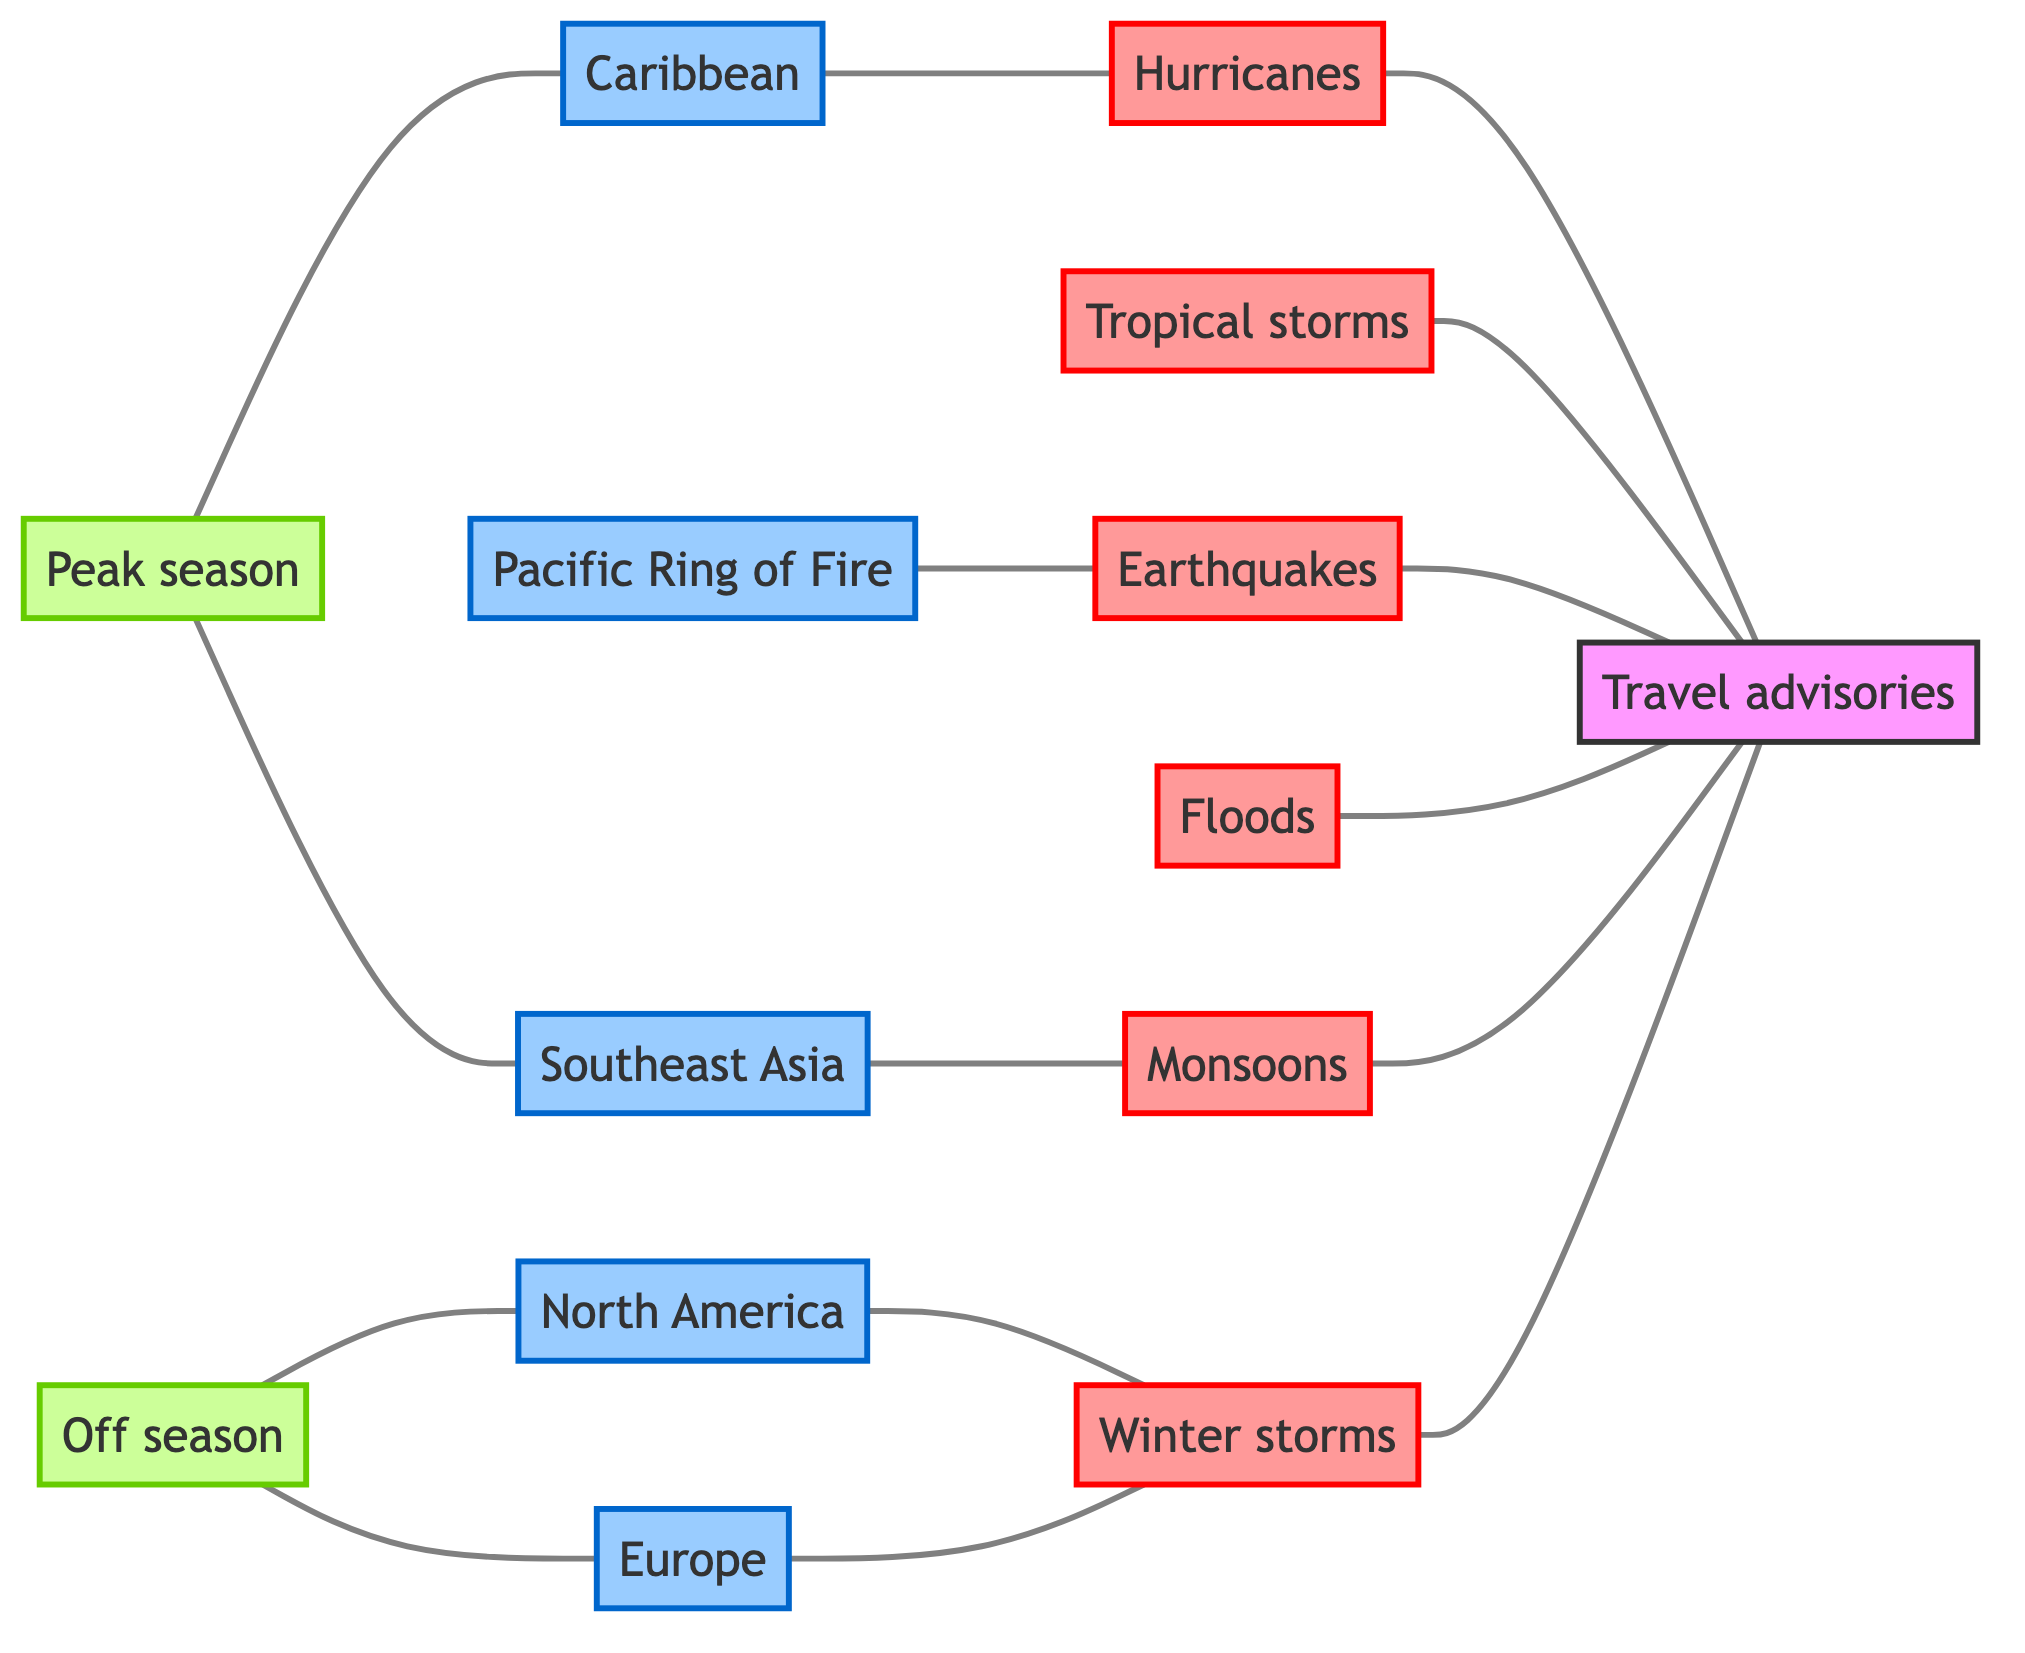What's the number of natural disaster nodes in the diagram? Count the nodes classified as disasters in the diagram. These are: Hurricanes, Tropical storms, Earthquakes, Floods, Monsoons, and Winter storms. Thus, there are six nodes labeled as natural disasters.
Answer: 6 Which region is associated with monsoons? Check the edges in the diagram to see which region connects to 'Monsoons'. The edge indicates that 'Southeast Asia' is linked to 'Monsoons'.
Answer: Southeast Asia How many types of travel advisories are influenced by natural disasters? Identify the connections from natural disaster nodes to the 'Travel advisories' node in the diagram. Since all six disaster nodes connect to 'Travel advisories', this indicates six types of advisories.
Answer: 6 Which region is directly linked to hurricanes? Review the edges connected to 'Hurricanes'. 'Caribbean' is directly linked to 'Hurricanes' in the diagram.
Answer: Caribbean Is there a connection between tropical storms and any specific travel advisory? Look for direct edges from 'Tropical storms' to other nodes. The 'Tropical storms' node connects directly to the 'Travel advisories' node, indicating a relationship.
Answer: Yes What are the two types of seasons represented in the diagram? The diagram contains the nodes 'Peak season' and 'Off season', which are both labeled as types of seasons.
Answer: Peak season, Off season Which natural disaster is associated with the Pacific Ring of Fire? Inspect the diagrams and edges for natural disasters linked to 'Pacific Ring of Fire'. The 'Earthquakes' node is connected to it, showing that earthquakes are relevant to this region.
Answer: Earthquakes What is the relationship between North America and winter storms? Examine the connection between 'North America' and 'Winter storms'. A direct edge shows a link, indicating that winter storms are relevant for North America.
Answer: Relevant Which region experiences tropical storms based on the diagram? Analyze the edges for any connection to 'Tropical storms'. There is no direct region tied; however, 'Tropical storms' and 'Travel advisories' connect, indicating a broader travel advisory context potentially applicable to multiple regions.
Answer: No specific region 